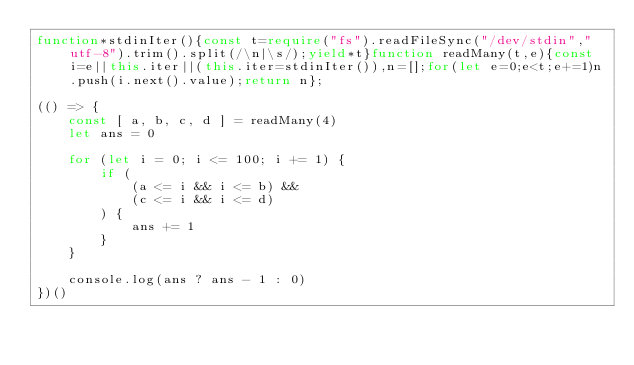<code> <loc_0><loc_0><loc_500><loc_500><_TypeScript_>function*stdinIter(){const t=require("fs").readFileSync("/dev/stdin","utf-8").trim().split(/\n|\s/);yield*t}function readMany(t,e){const i=e||this.iter||(this.iter=stdinIter()),n=[];for(let e=0;e<t;e+=1)n.push(i.next().value);return n};

(() => {
    const [ a, b, c, d ] = readMany(4)
    let ans = 0

    for (let i = 0; i <= 100; i += 1) {
        if (
            (a <= i && i <= b) &&
            (c <= i && i <= d)
        ) {
            ans += 1
        }
    }

    console.log(ans ? ans - 1 : 0)
})()
</code> 